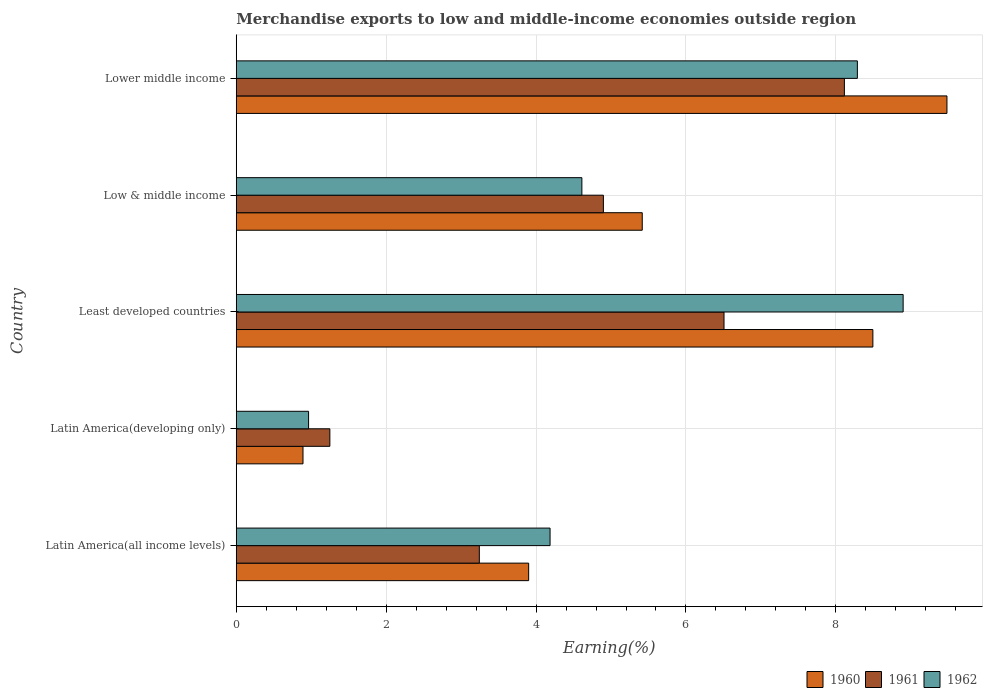Are the number of bars per tick equal to the number of legend labels?
Give a very brief answer. Yes. Are the number of bars on each tick of the Y-axis equal?
Offer a very short reply. Yes. How many bars are there on the 3rd tick from the bottom?
Make the answer very short. 3. What is the label of the 3rd group of bars from the top?
Offer a terse response. Least developed countries. In how many cases, is the number of bars for a given country not equal to the number of legend labels?
Give a very brief answer. 0. What is the percentage of amount earned from merchandise exports in 1961 in Low & middle income?
Offer a very short reply. 4.9. Across all countries, what is the maximum percentage of amount earned from merchandise exports in 1960?
Your answer should be very brief. 9.48. Across all countries, what is the minimum percentage of amount earned from merchandise exports in 1961?
Ensure brevity in your answer.  1.25. In which country was the percentage of amount earned from merchandise exports in 1961 maximum?
Your answer should be compact. Lower middle income. In which country was the percentage of amount earned from merchandise exports in 1962 minimum?
Make the answer very short. Latin America(developing only). What is the total percentage of amount earned from merchandise exports in 1960 in the graph?
Keep it short and to the point. 28.18. What is the difference between the percentage of amount earned from merchandise exports in 1962 in Low & middle income and that in Lower middle income?
Offer a very short reply. -3.68. What is the difference between the percentage of amount earned from merchandise exports in 1960 in Latin America(developing only) and the percentage of amount earned from merchandise exports in 1961 in Low & middle income?
Offer a terse response. -4.01. What is the average percentage of amount earned from merchandise exports in 1962 per country?
Offer a very short reply. 5.39. What is the difference between the percentage of amount earned from merchandise exports in 1962 and percentage of amount earned from merchandise exports in 1961 in Least developed countries?
Provide a short and direct response. 2.39. What is the ratio of the percentage of amount earned from merchandise exports in 1962 in Latin America(all income levels) to that in Latin America(developing only)?
Offer a terse response. 4.34. Is the percentage of amount earned from merchandise exports in 1960 in Latin America(all income levels) less than that in Lower middle income?
Offer a terse response. Yes. What is the difference between the highest and the second highest percentage of amount earned from merchandise exports in 1962?
Offer a very short reply. 0.61. What is the difference between the highest and the lowest percentage of amount earned from merchandise exports in 1961?
Ensure brevity in your answer.  6.86. What does the 3rd bar from the top in Lower middle income represents?
Ensure brevity in your answer.  1960. What does the 1st bar from the bottom in Latin America(developing only) represents?
Offer a very short reply. 1960. Is it the case that in every country, the sum of the percentage of amount earned from merchandise exports in 1962 and percentage of amount earned from merchandise exports in 1960 is greater than the percentage of amount earned from merchandise exports in 1961?
Offer a terse response. Yes. How many countries are there in the graph?
Keep it short and to the point. 5. Where does the legend appear in the graph?
Offer a terse response. Bottom right. How many legend labels are there?
Give a very brief answer. 3. What is the title of the graph?
Offer a terse response. Merchandise exports to low and middle-income economies outside region. Does "2007" appear as one of the legend labels in the graph?
Provide a succinct answer. No. What is the label or title of the X-axis?
Your response must be concise. Earning(%). What is the Earning(%) of 1960 in Latin America(all income levels)?
Offer a very short reply. 3.9. What is the Earning(%) of 1961 in Latin America(all income levels)?
Your answer should be very brief. 3.24. What is the Earning(%) in 1962 in Latin America(all income levels)?
Offer a terse response. 4.19. What is the Earning(%) of 1960 in Latin America(developing only)?
Provide a succinct answer. 0.89. What is the Earning(%) in 1961 in Latin America(developing only)?
Ensure brevity in your answer.  1.25. What is the Earning(%) of 1962 in Latin America(developing only)?
Offer a terse response. 0.97. What is the Earning(%) in 1960 in Least developed countries?
Ensure brevity in your answer.  8.49. What is the Earning(%) of 1961 in Least developed countries?
Give a very brief answer. 6.51. What is the Earning(%) in 1962 in Least developed countries?
Ensure brevity in your answer.  8.9. What is the Earning(%) of 1960 in Low & middle income?
Keep it short and to the point. 5.42. What is the Earning(%) of 1961 in Low & middle income?
Offer a very short reply. 4.9. What is the Earning(%) of 1962 in Low & middle income?
Provide a succinct answer. 4.61. What is the Earning(%) of 1960 in Lower middle income?
Ensure brevity in your answer.  9.48. What is the Earning(%) in 1961 in Lower middle income?
Provide a short and direct response. 8.11. What is the Earning(%) in 1962 in Lower middle income?
Your answer should be compact. 8.29. Across all countries, what is the maximum Earning(%) of 1960?
Offer a very short reply. 9.48. Across all countries, what is the maximum Earning(%) of 1961?
Keep it short and to the point. 8.11. Across all countries, what is the maximum Earning(%) of 1962?
Offer a terse response. 8.9. Across all countries, what is the minimum Earning(%) in 1960?
Your answer should be compact. 0.89. Across all countries, what is the minimum Earning(%) of 1961?
Give a very brief answer. 1.25. Across all countries, what is the minimum Earning(%) in 1962?
Provide a short and direct response. 0.97. What is the total Earning(%) in 1960 in the graph?
Provide a succinct answer. 28.18. What is the total Earning(%) in 1961 in the graph?
Your answer should be very brief. 24.01. What is the total Earning(%) in 1962 in the graph?
Provide a succinct answer. 26.95. What is the difference between the Earning(%) of 1960 in Latin America(all income levels) and that in Latin America(developing only)?
Provide a succinct answer. 3.01. What is the difference between the Earning(%) of 1961 in Latin America(all income levels) and that in Latin America(developing only)?
Your response must be concise. 1.99. What is the difference between the Earning(%) of 1962 in Latin America(all income levels) and that in Latin America(developing only)?
Offer a very short reply. 3.22. What is the difference between the Earning(%) of 1960 in Latin America(all income levels) and that in Least developed countries?
Provide a short and direct response. -4.59. What is the difference between the Earning(%) in 1961 in Latin America(all income levels) and that in Least developed countries?
Keep it short and to the point. -3.26. What is the difference between the Earning(%) of 1962 in Latin America(all income levels) and that in Least developed countries?
Offer a very short reply. -4.71. What is the difference between the Earning(%) in 1960 in Latin America(all income levels) and that in Low & middle income?
Your response must be concise. -1.52. What is the difference between the Earning(%) of 1961 in Latin America(all income levels) and that in Low & middle income?
Your answer should be very brief. -1.66. What is the difference between the Earning(%) of 1962 in Latin America(all income levels) and that in Low & middle income?
Make the answer very short. -0.42. What is the difference between the Earning(%) in 1960 in Latin America(all income levels) and that in Lower middle income?
Your answer should be very brief. -5.58. What is the difference between the Earning(%) in 1961 in Latin America(all income levels) and that in Lower middle income?
Keep it short and to the point. -4.87. What is the difference between the Earning(%) in 1962 in Latin America(all income levels) and that in Lower middle income?
Make the answer very short. -4.1. What is the difference between the Earning(%) in 1960 in Latin America(developing only) and that in Least developed countries?
Offer a terse response. -7.6. What is the difference between the Earning(%) in 1961 in Latin America(developing only) and that in Least developed countries?
Offer a very short reply. -5.26. What is the difference between the Earning(%) of 1962 in Latin America(developing only) and that in Least developed countries?
Provide a short and direct response. -7.93. What is the difference between the Earning(%) in 1960 in Latin America(developing only) and that in Low & middle income?
Provide a short and direct response. -4.53. What is the difference between the Earning(%) in 1961 in Latin America(developing only) and that in Low & middle income?
Give a very brief answer. -3.65. What is the difference between the Earning(%) of 1962 in Latin America(developing only) and that in Low & middle income?
Make the answer very short. -3.65. What is the difference between the Earning(%) in 1960 in Latin America(developing only) and that in Lower middle income?
Your answer should be very brief. -8.59. What is the difference between the Earning(%) of 1961 in Latin America(developing only) and that in Lower middle income?
Provide a succinct answer. -6.86. What is the difference between the Earning(%) in 1962 in Latin America(developing only) and that in Lower middle income?
Provide a succinct answer. -7.32. What is the difference between the Earning(%) of 1960 in Least developed countries and that in Low & middle income?
Keep it short and to the point. 3.08. What is the difference between the Earning(%) of 1961 in Least developed countries and that in Low & middle income?
Give a very brief answer. 1.61. What is the difference between the Earning(%) of 1962 in Least developed countries and that in Low & middle income?
Offer a very short reply. 4.29. What is the difference between the Earning(%) in 1960 in Least developed countries and that in Lower middle income?
Offer a terse response. -0.99. What is the difference between the Earning(%) of 1961 in Least developed countries and that in Lower middle income?
Offer a terse response. -1.61. What is the difference between the Earning(%) in 1962 in Least developed countries and that in Lower middle income?
Keep it short and to the point. 0.61. What is the difference between the Earning(%) in 1960 in Low & middle income and that in Lower middle income?
Provide a succinct answer. -4.07. What is the difference between the Earning(%) of 1961 in Low & middle income and that in Lower middle income?
Offer a terse response. -3.22. What is the difference between the Earning(%) in 1962 in Low & middle income and that in Lower middle income?
Offer a very short reply. -3.68. What is the difference between the Earning(%) in 1960 in Latin America(all income levels) and the Earning(%) in 1961 in Latin America(developing only)?
Ensure brevity in your answer.  2.65. What is the difference between the Earning(%) of 1960 in Latin America(all income levels) and the Earning(%) of 1962 in Latin America(developing only)?
Keep it short and to the point. 2.94. What is the difference between the Earning(%) of 1961 in Latin America(all income levels) and the Earning(%) of 1962 in Latin America(developing only)?
Your answer should be very brief. 2.28. What is the difference between the Earning(%) of 1960 in Latin America(all income levels) and the Earning(%) of 1961 in Least developed countries?
Your answer should be very brief. -2.61. What is the difference between the Earning(%) in 1960 in Latin America(all income levels) and the Earning(%) in 1962 in Least developed countries?
Ensure brevity in your answer.  -5. What is the difference between the Earning(%) in 1961 in Latin America(all income levels) and the Earning(%) in 1962 in Least developed countries?
Offer a terse response. -5.65. What is the difference between the Earning(%) of 1960 in Latin America(all income levels) and the Earning(%) of 1961 in Low & middle income?
Your response must be concise. -1. What is the difference between the Earning(%) in 1960 in Latin America(all income levels) and the Earning(%) in 1962 in Low & middle income?
Make the answer very short. -0.71. What is the difference between the Earning(%) in 1961 in Latin America(all income levels) and the Earning(%) in 1962 in Low & middle income?
Ensure brevity in your answer.  -1.37. What is the difference between the Earning(%) of 1960 in Latin America(all income levels) and the Earning(%) of 1961 in Lower middle income?
Your response must be concise. -4.21. What is the difference between the Earning(%) in 1960 in Latin America(all income levels) and the Earning(%) in 1962 in Lower middle income?
Offer a terse response. -4.39. What is the difference between the Earning(%) of 1961 in Latin America(all income levels) and the Earning(%) of 1962 in Lower middle income?
Provide a succinct answer. -5.04. What is the difference between the Earning(%) in 1960 in Latin America(developing only) and the Earning(%) in 1961 in Least developed countries?
Offer a very short reply. -5.62. What is the difference between the Earning(%) of 1960 in Latin America(developing only) and the Earning(%) of 1962 in Least developed countries?
Offer a terse response. -8.01. What is the difference between the Earning(%) of 1961 in Latin America(developing only) and the Earning(%) of 1962 in Least developed countries?
Provide a short and direct response. -7.65. What is the difference between the Earning(%) in 1960 in Latin America(developing only) and the Earning(%) in 1961 in Low & middle income?
Your answer should be compact. -4.01. What is the difference between the Earning(%) of 1960 in Latin America(developing only) and the Earning(%) of 1962 in Low & middle income?
Offer a terse response. -3.72. What is the difference between the Earning(%) in 1961 in Latin America(developing only) and the Earning(%) in 1962 in Low & middle income?
Ensure brevity in your answer.  -3.36. What is the difference between the Earning(%) in 1960 in Latin America(developing only) and the Earning(%) in 1961 in Lower middle income?
Provide a succinct answer. -7.22. What is the difference between the Earning(%) of 1960 in Latin America(developing only) and the Earning(%) of 1962 in Lower middle income?
Offer a terse response. -7.4. What is the difference between the Earning(%) in 1961 in Latin America(developing only) and the Earning(%) in 1962 in Lower middle income?
Keep it short and to the point. -7.04. What is the difference between the Earning(%) in 1960 in Least developed countries and the Earning(%) in 1961 in Low & middle income?
Keep it short and to the point. 3.6. What is the difference between the Earning(%) in 1960 in Least developed countries and the Earning(%) in 1962 in Low & middle income?
Provide a succinct answer. 3.88. What is the difference between the Earning(%) in 1961 in Least developed countries and the Earning(%) in 1962 in Low & middle income?
Ensure brevity in your answer.  1.9. What is the difference between the Earning(%) of 1960 in Least developed countries and the Earning(%) of 1961 in Lower middle income?
Give a very brief answer. 0.38. What is the difference between the Earning(%) of 1960 in Least developed countries and the Earning(%) of 1962 in Lower middle income?
Provide a succinct answer. 0.21. What is the difference between the Earning(%) in 1961 in Least developed countries and the Earning(%) in 1962 in Lower middle income?
Your response must be concise. -1.78. What is the difference between the Earning(%) in 1960 in Low & middle income and the Earning(%) in 1961 in Lower middle income?
Make the answer very short. -2.7. What is the difference between the Earning(%) in 1960 in Low & middle income and the Earning(%) in 1962 in Lower middle income?
Make the answer very short. -2.87. What is the difference between the Earning(%) in 1961 in Low & middle income and the Earning(%) in 1962 in Lower middle income?
Keep it short and to the point. -3.39. What is the average Earning(%) in 1960 per country?
Make the answer very short. 5.64. What is the average Earning(%) in 1961 per country?
Provide a succinct answer. 4.8. What is the average Earning(%) of 1962 per country?
Make the answer very short. 5.39. What is the difference between the Earning(%) of 1960 and Earning(%) of 1961 in Latin America(all income levels)?
Provide a succinct answer. 0.66. What is the difference between the Earning(%) of 1960 and Earning(%) of 1962 in Latin America(all income levels)?
Give a very brief answer. -0.29. What is the difference between the Earning(%) of 1961 and Earning(%) of 1962 in Latin America(all income levels)?
Ensure brevity in your answer.  -0.94. What is the difference between the Earning(%) of 1960 and Earning(%) of 1961 in Latin America(developing only)?
Offer a very short reply. -0.36. What is the difference between the Earning(%) of 1960 and Earning(%) of 1962 in Latin America(developing only)?
Provide a short and direct response. -0.07. What is the difference between the Earning(%) in 1961 and Earning(%) in 1962 in Latin America(developing only)?
Provide a succinct answer. 0.28. What is the difference between the Earning(%) in 1960 and Earning(%) in 1961 in Least developed countries?
Keep it short and to the point. 1.99. What is the difference between the Earning(%) of 1960 and Earning(%) of 1962 in Least developed countries?
Your response must be concise. -0.4. What is the difference between the Earning(%) in 1961 and Earning(%) in 1962 in Least developed countries?
Provide a succinct answer. -2.39. What is the difference between the Earning(%) of 1960 and Earning(%) of 1961 in Low & middle income?
Your answer should be very brief. 0.52. What is the difference between the Earning(%) of 1960 and Earning(%) of 1962 in Low & middle income?
Provide a succinct answer. 0.81. What is the difference between the Earning(%) of 1961 and Earning(%) of 1962 in Low & middle income?
Ensure brevity in your answer.  0.29. What is the difference between the Earning(%) in 1960 and Earning(%) in 1961 in Lower middle income?
Make the answer very short. 1.37. What is the difference between the Earning(%) of 1960 and Earning(%) of 1962 in Lower middle income?
Ensure brevity in your answer.  1.2. What is the difference between the Earning(%) of 1961 and Earning(%) of 1962 in Lower middle income?
Keep it short and to the point. -0.17. What is the ratio of the Earning(%) of 1960 in Latin America(all income levels) to that in Latin America(developing only)?
Offer a terse response. 4.38. What is the ratio of the Earning(%) in 1961 in Latin America(all income levels) to that in Latin America(developing only)?
Provide a succinct answer. 2.6. What is the ratio of the Earning(%) of 1962 in Latin America(all income levels) to that in Latin America(developing only)?
Ensure brevity in your answer.  4.34. What is the ratio of the Earning(%) in 1960 in Latin America(all income levels) to that in Least developed countries?
Your answer should be compact. 0.46. What is the ratio of the Earning(%) of 1961 in Latin America(all income levels) to that in Least developed countries?
Give a very brief answer. 0.5. What is the ratio of the Earning(%) of 1962 in Latin America(all income levels) to that in Least developed countries?
Keep it short and to the point. 0.47. What is the ratio of the Earning(%) of 1960 in Latin America(all income levels) to that in Low & middle income?
Give a very brief answer. 0.72. What is the ratio of the Earning(%) of 1961 in Latin America(all income levels) to that in Low & middle income?
Ensure brevity in your answer.  0.66. What is the ratio of the Earning(%) in 1962 in Latin America(all income levels) to that in Low & middle income?
Provide a succinct answer. 0.91. What is the ratio of the Earning(%) of 1960 in Latin America(all income levels) to that in Lower middle income?
Offer a very short reply. 0.41. What is the ratio of the Earning(%) of 1961 in Latin America(all income levels) to that in Lower middle income?
Offer a very short reply. 0.4. What is the ratio of the Earning(%) in 1962 in Latin America(all income levels) to that in Lower middle income?
Your response must be concise. 0.51. What is the ratio of the Earning(%) of 1960 in Latin America(developing only) to that in Least developed countries?
Your answer should be compact. 0.1. What is the ratio of the Earning(%) of 1961 in Latin America(developing only) to that in Least developed countries?
Ensure brevity in your answer.  0.19. What is the ratio of the Earning(%) of 1962 in Latin America(developing only) to that in Least developed countries?
Your answer should be very brief. 0.11. What is the ratio of the Earning(%) of 1960 in Latin America(developing only) to that in Low & middle income?
Offer a very short reply. 0.16. What is the ratio of the Earning(%) of 1961 in Latin America(developing only) to that in Low & middle income?
Offer a terse response. 0.26. What is the ratio of the Earning(%) of 1962 in Latin America(developing only) to that in Low & middle income?
Your answer should be compact. 0.21. What is the ratio of the Earning(%) in 1960 in Latin America(developing only) to that in Lower middle income?
Provide a short and direct response. 0.09. What is the ratio of the Earning(%) in 1961 in Latin America(developing only) to that in Lower middle income?
Ensure brevity in your answer.  0.15. What is the ratio of the Earning(%) in 1962 in Latin America(developing only) to that in Lower middle income?
Your answer should be very brief. 0.12. What is the ratio of the Earning(%) of 1960 in Least developed countries to that in Low & middle income?
Your response must be concise. 1.57. What is the ratio of the Earning(%) of 1961 in Least developed countries to that in Low & middle income?
Make the answer very short. 1.33. What is the ratio of the Earning(%) of 1962 in Least developed countries to that in Low & middle income?
Your answer should be very brief. 1.93. What is the ratio of the Earning(%) in 1960 in Least developed countries to that in Lower middle income?
Ensure brevity in your answer.  0.9. What is the ratio of the Earning(%) in 1961 in Least developed countries to that in Lower middle income?
Provide a succinct answer. 0.8. What is the ratio of the Earning(%) in 1962 in Least developed countries to that in Lower middle income?
Keep it short and to the point. 1.07. What is the ratio of the Earning(%) in 1960 in Low & middle income to that in Lower middle income?
Your answer should be compact. 0.57. What is the ratio of the Earning(%) in 1961 in Low & middle income to that in Lower middle income?
Ensure brevity in your answer.  0.6. What is the ratio of the Earning(%) of 1962 in Low & middle income to that in Lower middle income?
Provide a succinct answer. 0.56. What is the difference between the highest and the second highest Earning(%) of 1960?
Give a very brief answer. 0.99. What is the difference between the highest and the second highest Earning(%) in 1961?
Ensure brevity in your answer.  1.61. What is the difference between the highest and the second highest Earning(%) in 1962?
Make the answer very short. 0.61. What is the difference between the highest and the lowest Earning(%) of 1960?
Your answer should be compact. 8.59. What is the difference between the highest and the lowest Earning(%) in 1961?
Provide a succinct answer. 6.86. What is the difference between the highest and the lowest Earning(%) of 1962?
Keep it short and to the point. 7.93. 